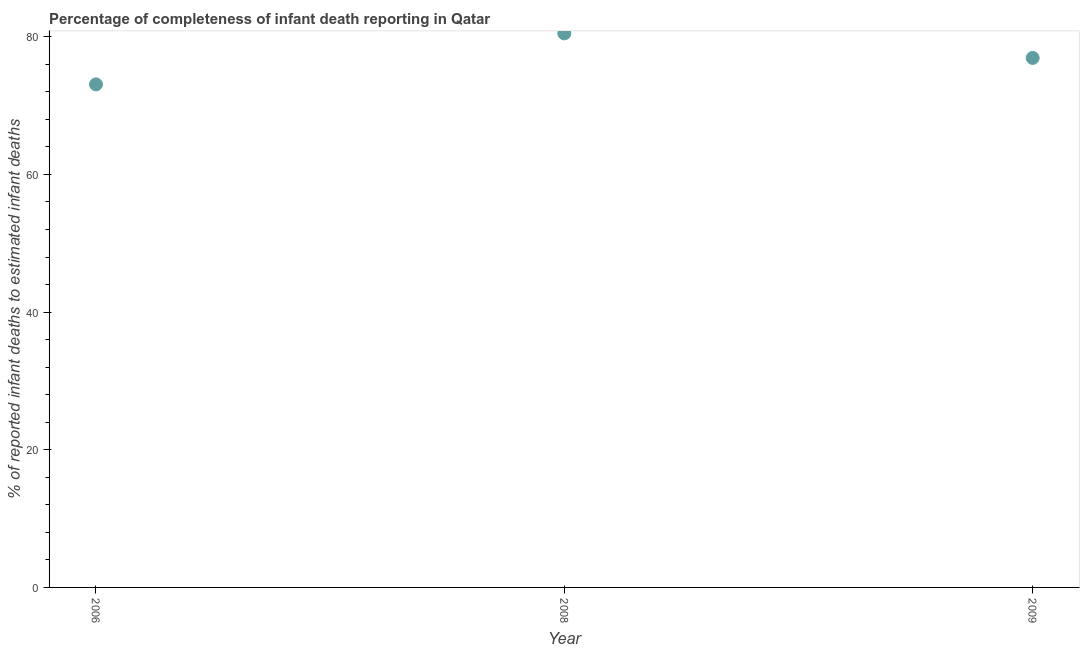What is the completeness of infant death reporting in 2009?
Offer a terse response. 76.92. Across all years, what is the maximum completeness of infant death reporting?
Give a very brief answer. 80.49. Across all years, what is the minimum completeness of infant death reporting?
Keep it short and to the point. 73.08. In which year was the completeness of infant death reporting maximum?
Offer a terse response. 2008. What is the sum of the completeness of infant death reporting?
Provide a short and direct response. 230.49. What is the difference between the completeness of infant death reporting in 2006 and 2008?
Offer a very short reply. -7.41. What is the average completeness of infant death reporting per year?
Offer a terse response. 76.83. What is the median completeness of infant death reporting?
Your answer should be compact. 76.92. Do a majority of the years between 2006 and 2008 (inclusive) have completeness of infant death reporting greater than 36 %?
Your answer should be compact. Yes. What is the ratio of the completeness of infant death reporting in 2008 to that in 2009?
Your answer should be compact. 1.05. Is the difference between the completeness of infant death reporting in 2006 and 2008 greater than the difference between any two years?
Offer a very short reply. Yes. What is the difference between the highest and the second highest completeness of infant death reporting?
Ensure brevity in your answer.  3.56. Is the sum of the completeness of infant death reporting in 2006 and 2009 greater than the maximum completeness of infant death reporting across all years?
Your answer should be compact. Yes. What is the difference between the highest and the lowest completeness of infant death reporting?
Your response must be concise. 7.41. Does the completeness of infant death reporting monotonically increase over the years?
Provide a succinct answer. No. How many dotlines are there?
Keep it short and to the point. 1. What is the difference between two consecutive major ticks on the Y-axis?
Give a very brief answer. 20. Are the values on the major ticks of Y-axis written in scientific E-notation?
Provide a succinct answer. No. Does the graph contain any zero values?
Your response must be concise. No. Does the graph contain grids?
Provide a succinct answer. No. What is the title of the graph?
Your answer should be compact. Percentage of completeness of infant death reporting in Qatar. What is the label or title of the Y-axis?
Your answer should be very brief. % of reported infant deaths to estimated infant deaths. What is the % of reported infant deaths to estimated infant deaths in 2006?
Your answer should be very brief. 73.08. What is the % of reported infant deaths to estimated infant deaths in 2008?
Your answer should be compact. 80.49. What is the % of reported infant deaths to estimated infant deaths in 2009?
Keep it short and to the point. 76.92. What is the difference between the % of reported infant deaths to estimated infant deaths in 2006 and 2008?
Offer a very short reply. -7.41. What is the difference between the % of reported infant deaths to estimated infant deaths in 2006 and 2009?
Your answer should be compact. -3.85. What is the difference between the % of reported infant deaths to estimated infant deaths in 2008 and 2009?
Make the answer very short. 3.56. What is the ratio of the % of reported infant deaths to estimated infant deaths in 2006 to that in 2008?
Your answer should be compact. 0.91. What is the ratio of the % of reported infant deaths to estimated infant deaths in 2006 to that in 2009?
Your response must be concise. 0.95. What is the ratio of the % of reported infant deaths to estimated infant deaths in 2008 to that in 2009?
Give a very brief answer. 1.05. 